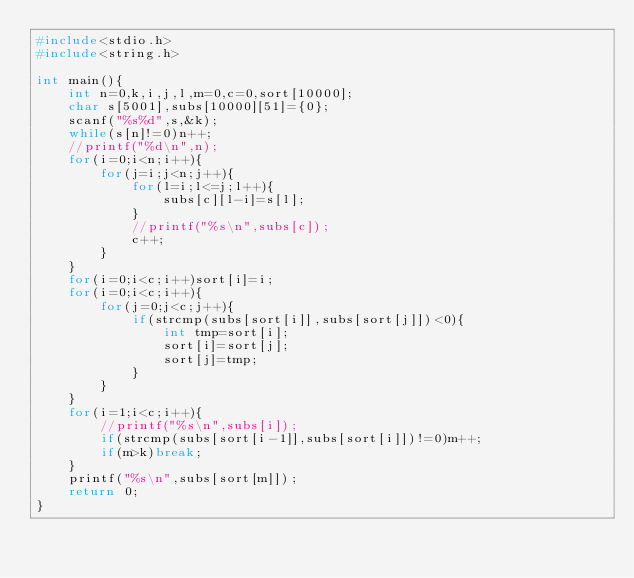<code> <loc_0><loc_0><loc_500><loc_500><_C_>#include<stdio.h>
#include<string.h>

int main(){
		int n=0,k,i,j,l,m=0,c=0,sort[10000];
		char s[5001],subs[10000][51]={0};
		scanf("%s%d",s,&k);
		while(s[n]!=0)n++;
		//printf("%d\n",n);
		for(i=0;i<n;i++){
				for(j=i;j<n;j++){
						for(l=i;l<=j;l++){
								subs[c][l-i]=s[l];
						}
						//printf("%s\n",subs[c]);
						c++;
				}
		}
		for(i=0;i<c;i++)sort[i]=i;
		for(i=0;i<c;i++){
				for(j=0;j<c;j++){
						if(strcmp(subs[sort[i]],subs[sort[j]])<0){
								int tmp=sort[i];
								sort[i]=sort[j];
								sort[j]=tmp;
						}
				}
		}
		for(i=1;i<c;i++){
				//printf("%s\n",subs[i]);
				if(strcmp(subs[sort[i-1]],subs[sort[i]])!=0)m++;
				if(m>k)break;
		}
		printf("%s\n",subs[sort[m]]);
		return 0;
}
</code> 